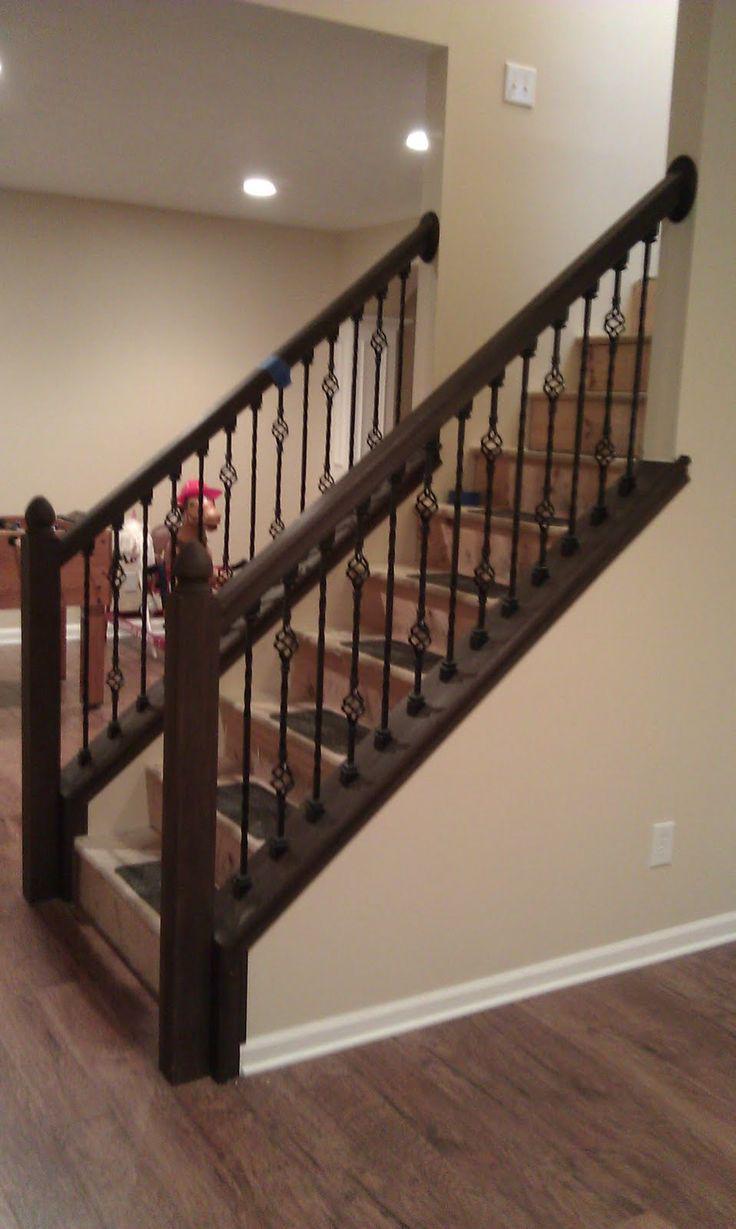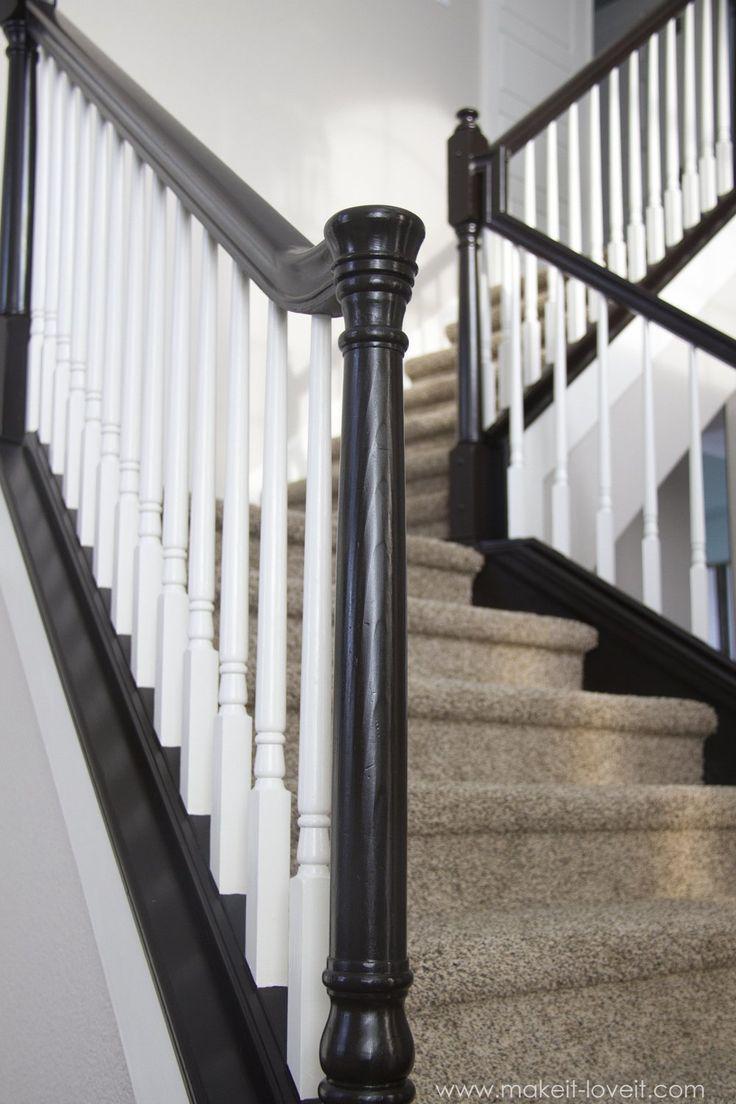The first image is the image on the left, the second image is the image on the right. For the images shown, is this caption "One image in the pair shows carpeted stairs and the other shows uncarpeted stairs." true? Answer yes or no. Yes. The first image is the image on the left, the second image is the image on the right. Analyze the images presented: Is the assertion "All the vertical stairway railings are black." valid? Answer yes or no. No. 